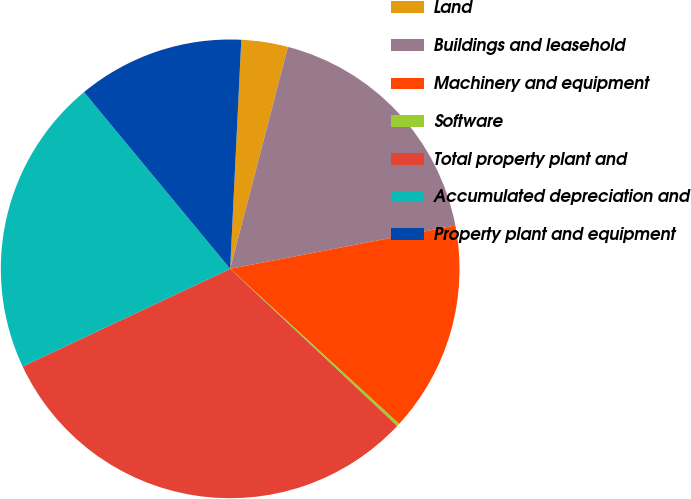Convert chart. <chart><loc_0><loc_0><loc_500><loc_500><pie_chart><fcel>Land<fcel>Buildings and leasehold<fcel>Machinery and equipment<fcel>Software<fcel>Total property plant and<fcel>Accumulated depreciation and<fcel>Property plant and equipment<nl><fcel>3.28%<fcel>17.92%<fcel>14.84%<fcel>0.2%<fcel>30.98%<fcel>21.0%<fcel>11.77%<nl></chart> 